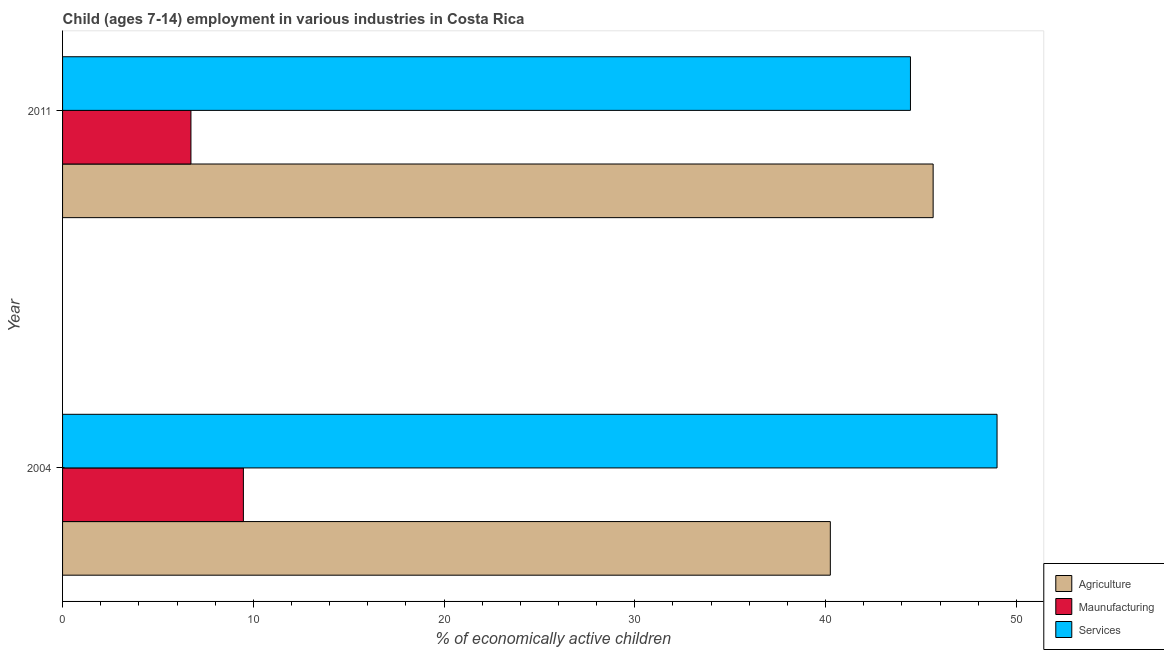How many different coloured bars are there?
Your answer should be compact. 3. Are the number of bars per tick equal to the number of legend labels?
Offer a very short reply. Yes. What is the label of the 1st group of bars from the top?
Keep it short and to the point. 2011. In how many cases, is the number of bars for a given year not equal to the number of legend labels?
Your response must be concise. 0. What is the percentage of economically active children in services in 2011?
Make the answer very short. 44.45. Across all years, what is the maximum percentage of economically active children in agriculture?
Offer a very short reply. 45.64. Across all years, what is the minimum percentage of economically active children in manufacturing?
Your response must be concise. 6.73. In which year was the percentage of economically active children in manufacturing minimum?
Offer a very short reply. 2011. What is the total percentage of economically active children in services in the graph?
Offer a very short reply. 93.44. What is the difference between the percentage of economically active children in manufacturing in 2004 and that in 2011?
Provide a short and direct response. 2.75. What is the difference between the percentage of economically active children in services in 2004 and the percentage of economically active children in agriculture in 2011?
Give a very brief answer. 3.35. What is the average percentage of economically active children in agriculture per year?
Your answer should be very brief. 42.95. In the year 2004, what is the difference between the percentage of economically active children in manufacturing and percentage of economically active children in agriculture?
Your answer should be compact. -30.77. In how many years, is the percentage of economically active children in services greater than 24 %?
Your response must be concise. 2. What is the ratio of the percentage of economically active children in agriculture in 2004 to that in 2011?
Ensure brevity in your answer.  0.88. Is the difference between the percentage of economically active children in manufacturing in 2004 and 2011 greater than the difference between the percentage of economically active children in services in 2004 and 2011?
Offer a terse response. No. In how many years, is the percentage of economically active children in agriculture greater than the average percentage of economically active children in agriculture taken over all years?
Your answer should be compact. 1. What does the 2nd bar from the top in 2011 represents?
Your answer should be compact. Maunufacturing. What does the 1st bar from the bottom in 2004 represents?
Keep it short and to the point. Agriculture. How many bars are there?
Make the answer very short. 6. What is the difference between two consecutive major ticks on the X-axis?
Ensure brevity in your answer.  10. Are the values on the major ticks of X-axis written in scientific E-notation?
Your response must be concise. No. Does the graph contain grids?
Offer a terse response. No. How are the legend labels stacked?
Your answer should be compact. Vertical. What is the title of the graph?
Offer a terse response. Child (ages 7-14) employment in various industries in Costa Rica. Does "Agricultural raw materials" appear as one of the legend labels in the graph?
Your response must be concise. No. What is the label or title of the X-axis?
Make the answer very short. % of economically active children. What is the % of economically active children of Agriculture in 2004?
Make the answer very short. 40.25. What is the % of economically active children in Maunufacturing in 2004?
Your answer should be compact. 9.48. What is the % of economically active children in Services in 2004?
Give a very brief answer. 48.99. What is the % of economically active children of Agriculture in 2011?
Offer a terse response. 45.64. What is the % of economically active children of Maunufacturing in 2011?
Your answer should be compact. 6.73. What is the % of economically active children in Services in 2011?
Provide a succinct answer. 44.45. Across all years, what is the maximum % of economically active children of Agriculture?
Your answer should be compact. 45.64. Across all years, what is the maximum % of economically active children in Maunufacturing?
Keep it short and to the point. 9.48. Across all years, what is the maximum % of economically active children in Services?
Make the answer very short. 48.99. Across all years, what is the minimum % of economically active children of Agriculture?
Ensure brevity in your answer.  40.25. Across all years, what is the minimum % of economically active children in Maunufacturing?
Your answer should be compact. 6.73. Across all years, what is the minimum % of economically active children of Services?
Keep it short and to the point. 44.45. What is the total % of economically active children in Agriculture in the graph?
Give a very brief answer. 85.89. What is the total % of economically active children in Maunufacturing in the graph?
Offer a very short reply. 16.21. What is the total % of economically active children in Services in the graph?
Give a very brief answer. 93.44. What is the difference between the % of economically active children of Agriculture in 2004 and that in 2011?
Keep it short and to the point. -5.39. What is the difference between the % of economically active children in Maunufacturing in 2004 and that in 2011?
Your answer should be compact. 2.75. What is the difference between the % of economically active children in Services in 2004 and that in 2011?
Provide a short and direct response. 4.54. What is the difference between the % of economically active children in Agriculture in 2004 and the % of economically active children in Maunufacturing in 2011?
Your answer should be very brief. 33.52. What is the difference between the % of economically active children in Maunufacturing in 2004 and the % of economically active children in Services in 2011?
Offer a terse response. -34.97. What is the average % of economically active children of Agriculture per year?
Your answer should be compact. 42.95. What is the average % of economically active children in Maunufacturing per year?
Offer a terse response. 8.11. What is the average % of economically active children of Services per year?
Offer a very short reply. 46.72. In the year 2004, what is the difference between the % of economically active children in Agriculture and % of economically active children in Maunufacturing?
Offer a terse response. 30.77. In the year 2004, what is the difference between the % of economically active children of Agriculture and % of economically active children of Services?
Your answer should be compact. -8.74. In the year 2004, what is the difference between the % of economically active children of Maunufacturing and % of economically active children of Services?
Make the answer very short. -39.51. In the year 2011, what is the difference between the % of economically active children in Agriculture and % of economically active children in Maunufacturing?
Your answer should be very brief. 38.91. In the year 2011, what is the difference between the % of economically active children in Agriculture and % of economically active children in Services?
Give a very brief answer. 1.19. In the year 2011, what is the difference between the % of economically active children of Maunufacturing and % of economically active children of Services?
Your answer should be compact. -37.72. What is the ratio of the % of economically active children of Agriculture in 2004 to that in 2011?
Make the answer very short. 0.88. What is the ratio of the % of economically active children of Maunufacturing in 2004 to that in 2011?
Offer a terse response. 1.41. What is the ratio of the % of economically active children in Services in 2004 to that in 2011?
Your answer should be compact. 1.1. What is the difference between the highest and the second highest % of economically active children of Agriculture?
Offer a very short reply. 5.39. What is the difference between the highest and the second highest % of economically active children of Maunufacturing?
Provide a short and direct response. 2.75. What is the difference between the highest and the second highest % of economically active children in Services?
Your answer should be very brief. 4.54. What is the difference between the highest and the lowest % of economically active children of Agriculture?
Provide a short and direct response. 5.39. What is the difference between the highest and the lowest % of economically active children of Maunufacturing?
Your response must be concise. 2.75. What is the difference between the highest and the lowest % of economically active children in Services?
Offer a terse response. 4.54. 